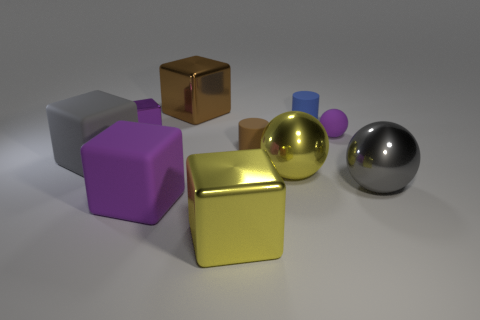Subtract all tiny purple spheres. How many spheres are left? 2 Subtract all balls. How many objects are left? 7 Add 1 small brown balls. How many small brown balls exist? 1 Subtract all gray spheres. How many spheres are left? 2 Subtract 0 yellow cylinders. How many objects are left? 10 Subtract 2 balls. How many balls are left? 1 Subtract all cyan spheres. Subtract all brown blocks. How many spheres are left? 3 Subtract all purple balls. How many blue cylinders are left? 1 Subtract all small purple rubber things. Subtract all matte balls. How many objects are left? 8 Add 1 blue rubber objects. How many blue rubber objects are left? 2 